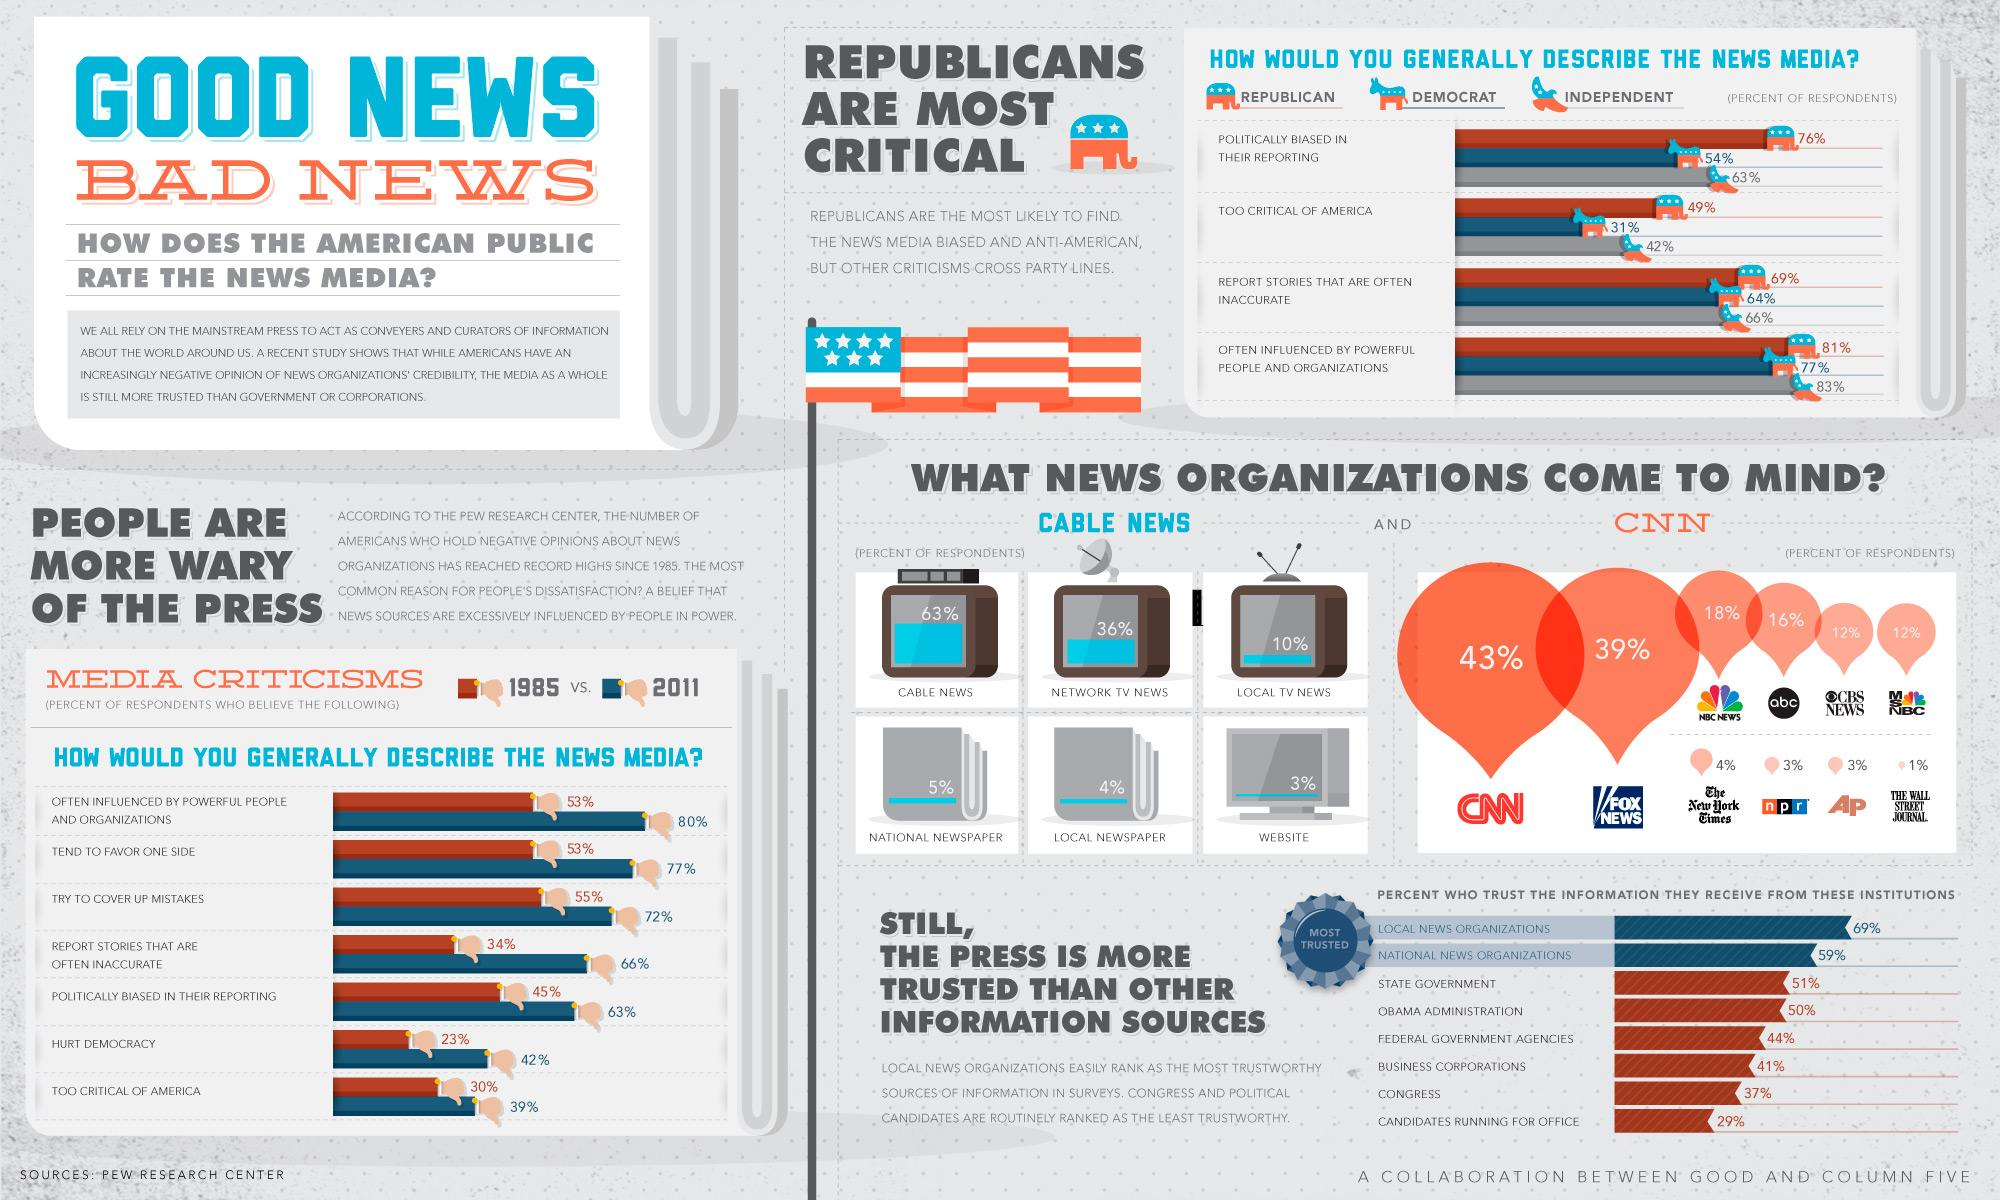Give some essential details in this illustration. State Government is the third most trusted organization, according to a recent survey. 